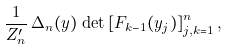<formula> <loc_0><loc_0><loc_500><loc_500>\frac { 1 } { { Z } _ { n } ^ { \prime } } \, \Delta _ { n } ( y ) \, \det \left [ F _ { k - 1 } ( y _ { j } ) \right ] _ { j , k = 1 } ^ { n } ,</formula> 